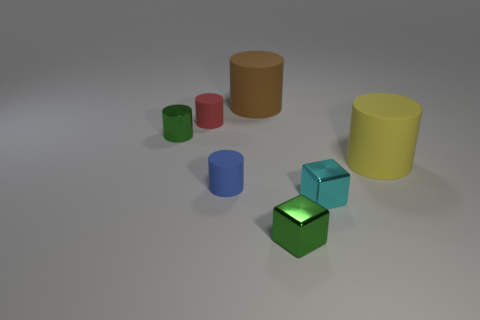Subtract all blue cylinders. How many cylinders are left? 4 Subtract all tiny green shiny cylinders. How many cylinders are left? 4 Subtract all cyan cylinders. Subtract all green balls. How many cylinders are left? 5 Add 1 blue shiny balls. How many objects exist? 8 Subtract all blocks. How many objects are left? 5 Subtract all small blue metal blocks. Subtract all blue things. How many objects are left? 6 Add 4 big yellow rubber objects. How many big yellow rubber objects are left? 5 Add 6 green shiny cubes. How many green shiny cubes exist? 7 Subtract 1 blue cylinders. How many objects are left? 6 